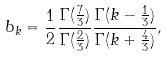Convert formula to latex. <formula><loc_0><loc_0><loc_500><loc_500>b _ { k } = \frac { 1 } { 2 } \frac { \Gamma ( \frac { 7 } { 3 } ) } { \Gamma ( \frac { 2 } { 3 } ) } \frac { \Gamma ( k - \frac { 1 } { 3 } ) } { \Gamma ( k + \frac { 4 } { 3 } ) } ,</formula> 